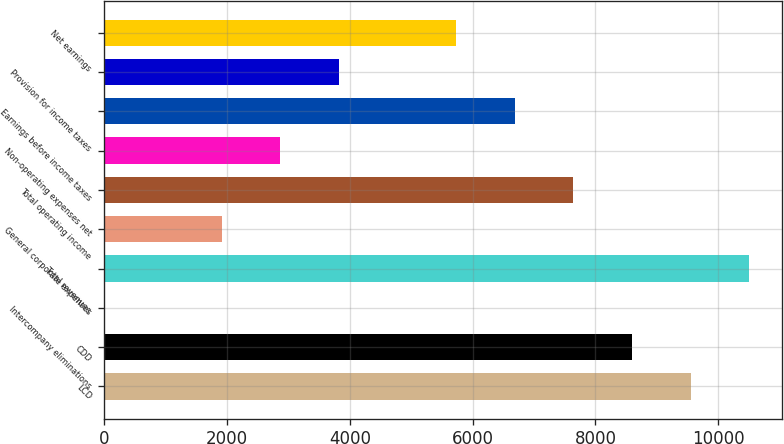<chart> <loc_0><loc_0><loc_500><loc_500><bar_chart><fcel>LCD<fcel>CDD<fcel>Intercompany eliminations<fcel>Total revenues<fcel>General corporate expenses<fcel>Total operating income<fcel>Non-operating expenses net<fcel>Earnings before income taxes<fcel>Provision for income taxes<fcel>Net earnings<nl><fcel>9552.9<fcel>8597.66<fcel>0.5<fcel>10508.1<fcel>1910.98<fcel>7642.42<fcel>2866.22<fcel>6687.18<fcel>3821.46<fcel>5731.94<nl></chart> 